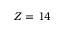Convert formula to latex. <formula><loc_0><loc_0><loc_500><loc_500>Z = 1 4</formula> 